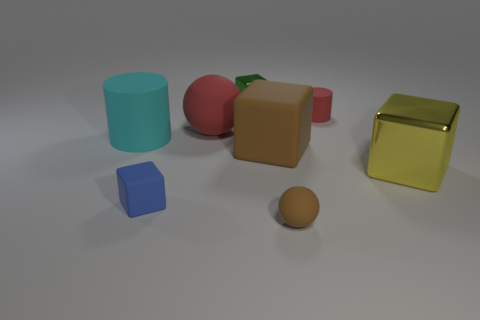Subtract 2 cubes. How many cubes are left? 2 Subtract all green cubes. How many cubes are left? 3 Subtract all red cubes. Subtract all yellow cylinders. How many cubes are left? 4 Add 1 big balls. How many objects exist? 9 Subtract all spheres. How many objects are left? 6 Add 7 large metal cubes. How many large metal cubes exist? 8 Subtract 1 red cylinders. How many objects are left? 7 Subtract all spheres. Subtract all tiny green shiny cubes. How many objects are left? 5 Add 5 brown balls. How many brown balls are left? 6 